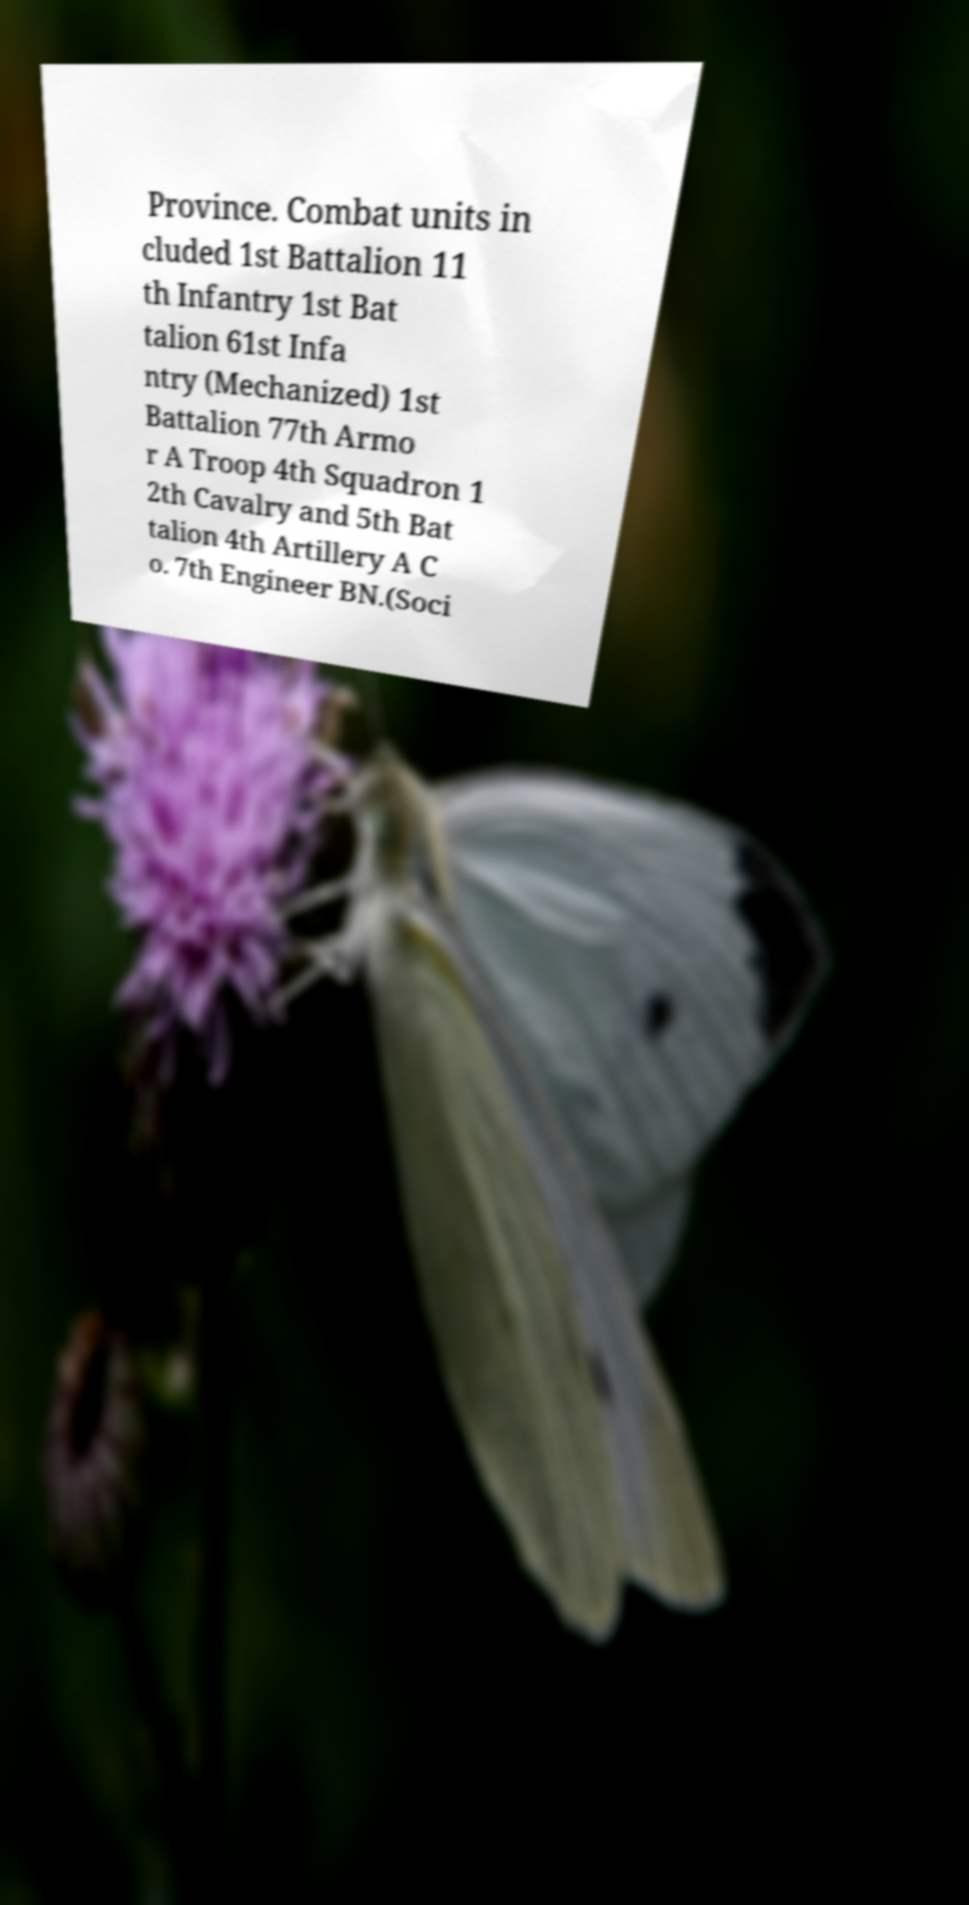Please identify and transcribe the text found in this image. Province. Combat units in cluded 1st Battalion 11 th Infantry 1st Bat talion 61st Infa ntry (Mechanized) 1st Battalion 77th Armo r A Troop 4th Squadron 1 2th Cavalry and 5th Bat talion 4th Artillery A C o. 7th Engineer BN.(Soci 